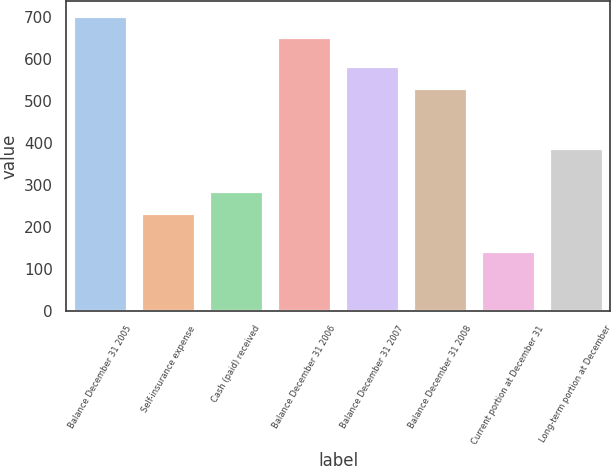<chart> <loc_0><loc_0><loc_500><loc_500><bar_chart><fcel>Balance December 31 2005<fcel>Self-insurance expense<fcel>Cash (paid) received<fcel>Balance December 31 2006<fcel>Balance December 31 2007<fcel>Balance December 31 2008<fcel>Current portion at December 31<fcel>Long-term portion at December<nl><fcel>703.8<fcel>233<fcel>284.8<fcel>652<fcel>582.8<fcel>531<fcel>142<fcel>389<nl></chart> 